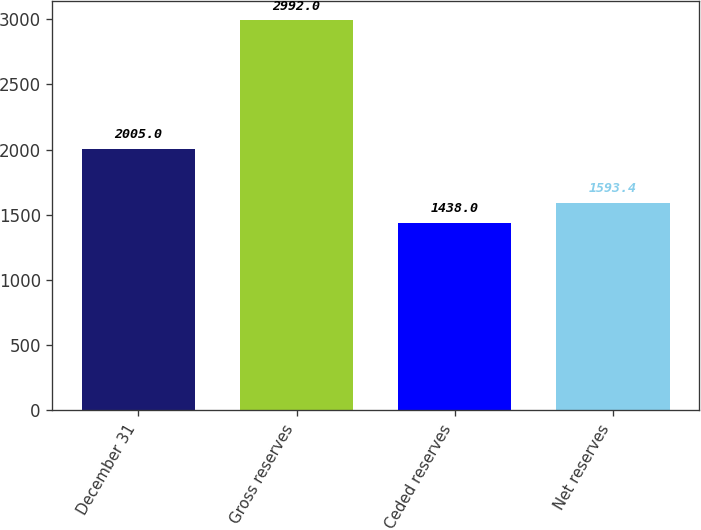<chart> <loc_0><loc_0><loc_500><loc_500><bar_chart><fcel>December 31<fcel>Gross reserves<fcel>Ceded reserves<fcel>Net reserves<nl><fcel>2005<fcel>2992<fcel>1438<fcel>1593.4<nl></chart> 